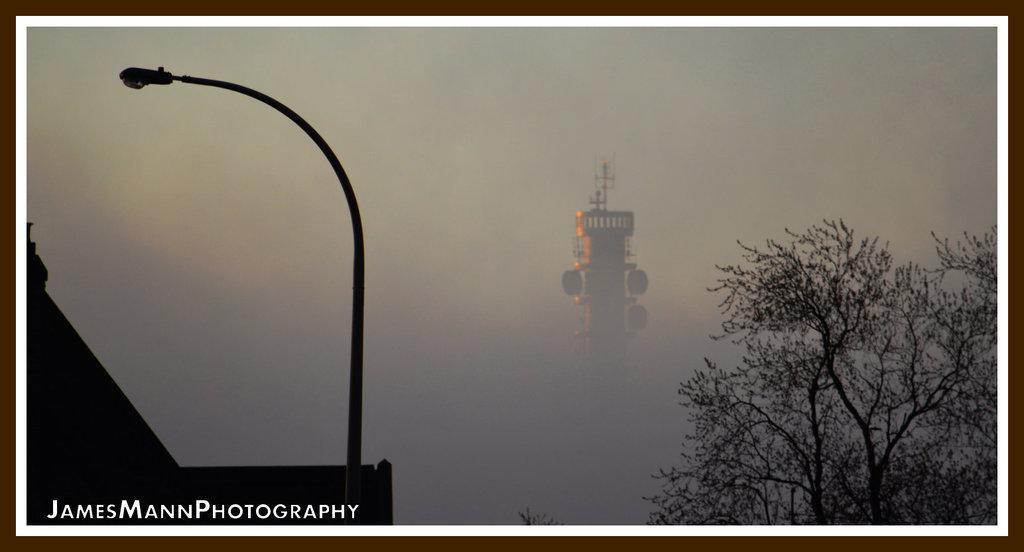Please provide a concise description of this image. In the center of the image there is a tower. On the right we can see a tree. On the left we can see a pole and a light. In the background there is sky. 